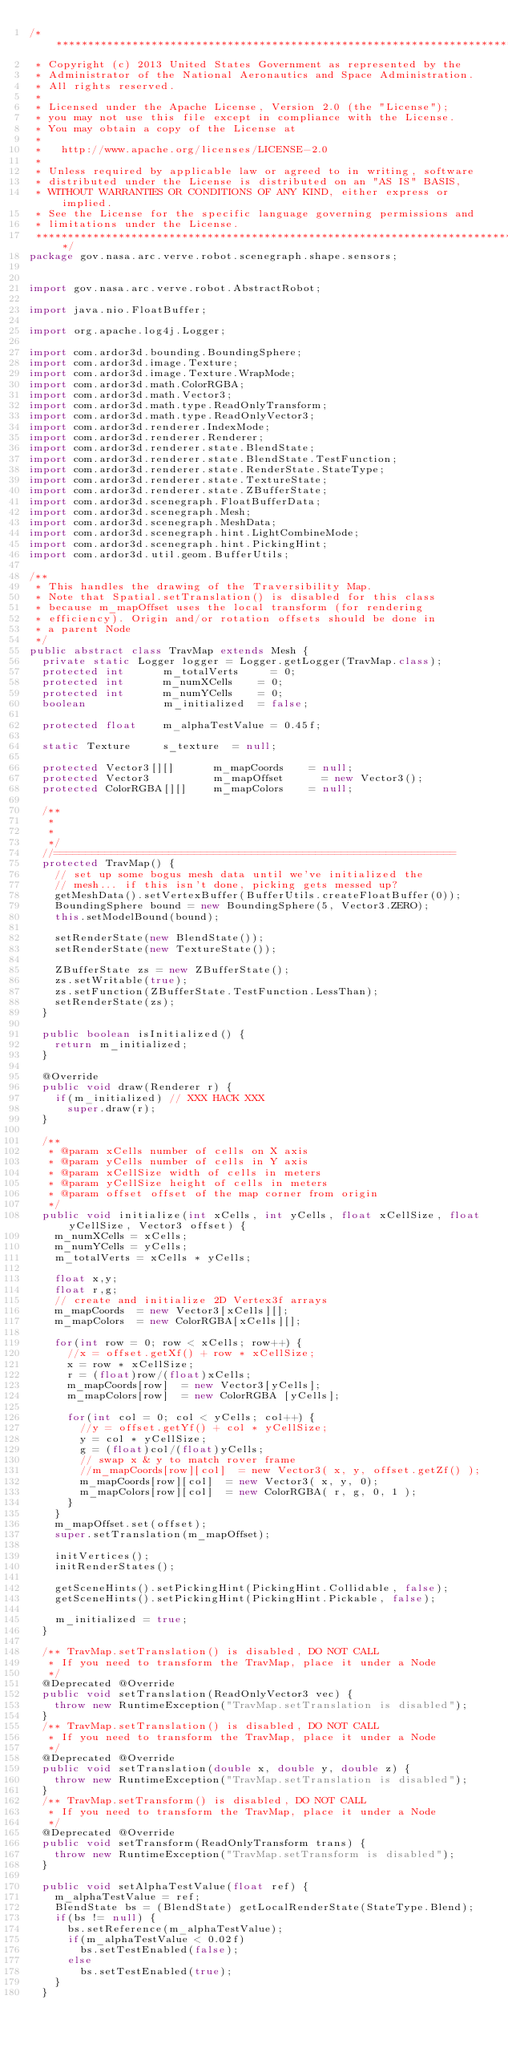<code> <loc_0><loc_0><loc_500><loc_500><_Java_>/*******************************************************************************
 * Copyright (c) 2013 United States Government as represented by the 
 * Administrator of the National Aeronautics and Space Administration. 
 * All rights reserved.
 * 
 * Licensed under the Apache License, Version 2.0 (the "License");
 * you may not use this file except in compliance with the License.
 * You may obtain a copy of the License at
 * 
 *   http://www.apache.org/licenses/LICENSE-2.0
 * 
 * Unless required by applicable law or agreed to in writing, software
 * distributed under the License is distributed on an "AS IS" BASIS,
 * WITHOUT WARRANTIES OR CONDITIONS OF ANY KIND, either express or implied.
 * See the License for the specific language governing permissions and
 * limitations under the License.
 ******************************************************************************/
package gov.nasa.arc.verve.robot.scenegraph.shape.sensors;


import gov.nasa.arc.verve.robot.AbstractRobot;

import java.nio.FloatBuffer;

import org.apache.log4j.Logger;

import com.ardor3d.bounding.BoundingSphere;
import com.ardor3d.image.Texture;
import com.ardor3d.image.Texture.WrapMode;
import com.ardor3d.math.ColorRGBA;
import com.ardor3d.math.Vector3;
import com.ardor3d.math.type.ReadOnlyTransform;
import com.ardor3d.math.type.ReadOnlyVector3;
import com.ardor3d.renderer.IndexMode;
import com.ardor3d.renderer.Renderer;
import com.ardor3d.renderer.state.BlendState;
import com.ardor3d.renderer.state.BlendState.TestFunction;
import com.ardor3d.renderer.state.RenderState.StateType;
import com.ardor3d.renderer.state.TextureState;
import com.ardor3d.renderer.state.ZBufferState;
import com.ardor3d.scenegraph.FloatBufferData;
import com.ardor3d.scenegraph.Mesh;
import com.ardor3d.scenegraph.MeshData;
import com.ardor3d.scenegraph.hint.LightCombineMode;
import com.ardor3d.scenegraph.hint.PickingHint;
import com.ardor3d.util.geom.BufferUtils;

/**
 * This handles the drawing of the Traversibility Map. 
 * Note that Spatial.setTranslation() is disabled for this class 
 * because m_mapOffset uses the local transform (for rendering
 * efficiency). Origin and/or rotation offsets should be done in
 * a parent Node
 */
public abstract class TravMap extends Mesh {	
	private static Logger logger = Logger.getLogger(TravMap.class);
	protected int      m_totalVerts	    = 0;	
	protected int      m_numXCells		= 0;	
	protected int      m_numYCells		= 0;	
	boolean            m_initialized	= false;

	protected float    m_alphaTestValue = 0.45f;

	static Texture     s_texture	= null;

	protected Vector3[][]      m_mapCoords		= null;
	protected Vector3          m_mapOffset      = new Vector3();
	protected ColorRGBA[][]    m_mapColors		= null;

	/**
	 * 
	 *
	 */
	//===============================================================
	protected TravMap() {
		// set up some bogus mesh data until we've initialized the 
		// mesh... if this isn't done, picking gets messed up?
		getMeshData().setVertexBuffer(BufferUtils.createFloatBuffer(0));
		BoundingSphere bound = new BoundingSphere(5, Vector3.ZERO);
		this.setModelBound(bound);

		setRenderState(new BlendState());
		setRenderState(new TextureState());

		ZBufferState zs = new ZBufferState();
		zs.setWritable(true);
		zs.setFunction(ZBufferState.TestFunction.LessThan);  
		setRenderState(zs);
	}

	public boolean isInitialized() {
		return m_initialized;
	}

	@Override
	public void draw(Renderer r) {
		if(m_initialized) // XXX HACK XXX
			super.draw(r);
	}

	/**
	 * @param xCells number of cells on X axis
	 * @param yCells number of cells in Y axis
	 * @param xCellSize width of cells in meters
	 * @param yCellSize height of cells in meters
	 * @param offset offset of the map corner from origin
	 */
	public void initialize(int xCells, int yCells, float xCellSize, float yCellSize, Vector3 offset) {
		m_numXCells	= xCells;
		m_numYCells	= yCells;
		m_totalVerts = xCells * yCells;

		float x,y;
		float r,g;
		// create and initialize 2D Vertex3f arrays
		m_mapCoords  = new Vector3[xCells][];
		m_mapColors  = new ColorRGBA[xCells][];

		for(int row = 0; row < xCells; row++) {
			//x = offset.getXf() + row * xCellSize;
			x = row * xCellSize;
			r = (float)row/(float)xCells;
			m_mapCoords[row]  = new Vector3[yCells];
			m_mapColors[row]  = new ColorRGBA [yCells];

			for(int col = 0; col < yCells; col++) {
				//y = offset.getYf() + col * yCellSize;
				y = col * yCellSize;
				g = (float)col/(float)yCells;
				// swap x & y to match rover frame
				//m_mapCoords[row][col]  = new Vector3( x, y, offset.getZf() );
				m_mapCoords[row][col]  = new Vector3( x, y, 0);
				m_mapColors[row][col]  = new ColorRGBA( r, g, 0, 1 );
			}
		}
		m_mapOffset.set(offset);
		super.setTranslation(m_mapOffset);

		initVertices();
		initRenderStates();

		getSceneHints().setPickingHint(PickingHint.Collidable, false);
		getSceneHints().setPickingHint(PickingHint.Pickable, false);

		m_initialized = true;
	}

	/** TravMap.setTranslation() is disabled, DO NOT CALL
	 * If you need to transform the TravMap, place it under a Node
	 */ 
	@Deprecated @Override
	public void setTranslation(ReadOnlyVector3 vec) {
		throw new RuntimeException("TravMap.setTranslation is disabled");
	}
	/** TravMap.setTranslation() is disabled, DO NOT CALL
	 * If you need to transform the TravMap, place it under a Node
	 */ 
	@Deprecated @Override
	public void setTranslation(double x, double y, double z) {
		throw new RuntimeException("TravMap.setTranslation is disabled");
	}
	/** TravMap.setTransform() is disabled, DO NOT CALL
	 * If you need to transform the TravMap, place it under a Node
	 */
	@Deprecated @Override
	public void setTransform(ReadOnlyTransform trans) {
		throw new RuntimeException("TravMap.setTransform is disabled");
	}

	public void setAlphaTestValue(float ref) {
		m_alphaTestValue = ref;
		BlendState bs = (BlendState) getLocalRenderState(StateType.Blend); 
		if(bs != null) {
			bs.setReference(m_alphaTestValue);
			if(m_alphaTestValue < 0.02f)
				bs.setTestEnabled(false);
			else
				bs.setTestEnabled(true);
		}
	}
</code> 